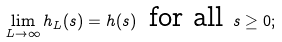<formula> <loc_0><loc_0><loc_500><loc_500>\lim _ { L \rightarrow \infty } h _ { L } ( s ) = h ( s ) \, \text { for all } s \geq 0 ;</formula> 